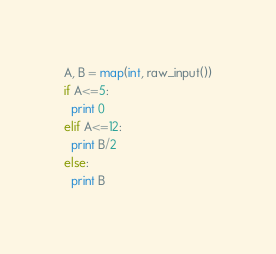<code> <loc_0><loc_0><loc_500><loc_500><_Python_>A, B = map(int, raw_input())
if A<=5:
  print 0
elif A<=12:
  print B/2
else:
  print B
</code> 